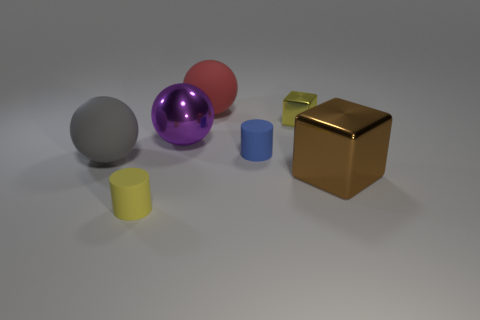Add 3 large gray balls. How many objects exist? 10 Subtract all cylinders. How many objects are left? 5 Add 2 big red rubber blocks. How many big red rubber blocks exist? 2 Subtract 0 blue spheres. How many objects are left? 7 Subtract all large red matte spheres. Subtract all blocks. How many objects are left? 4 Add 4 blue rubber objects. How many blue rubber objects are left? 5 